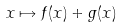<formula> <loc_0><loc_0><loc_500><loc_500>x \mapsto f ( x ) + g ( x )</formula> 